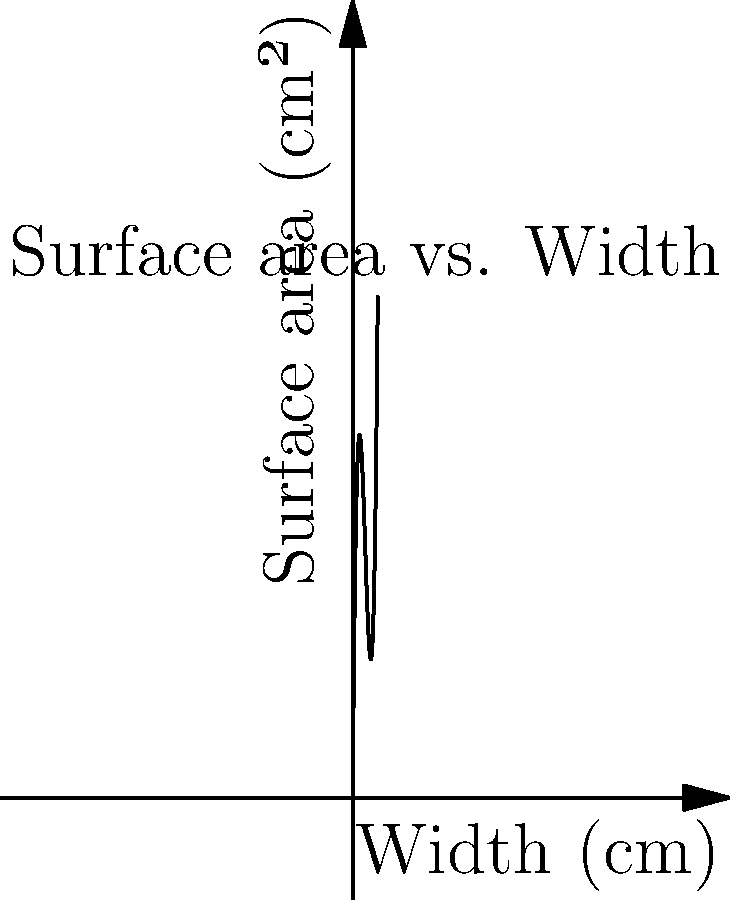As a seller of traditional Turkish decorations, you want to create a rectangular display case for a special Ottoman-era vase. The case should have a square base with width $x$ cm and height $10$ cm. The total surface area $S$ of the case is given by the function $S(x) = 2x^3 - 30x^2 + 120x$. What dimensions should you choose to minimize the surface area while ensuring the case has a volume of at least 1000 cm³? Let's approach this step-by-step:

1) First, we need to find the critical points of the surface area function:
   $S(x) = 2x^3 - 30x^2 + 120x$
   $S'(x) = 6x^2 - 60x + 120$
   Set $S'(x) = 0$:
   $6x^2 - 60x + 120 = 0$
   $x^2 - 10x + 20 = 0$
   $(x-5)^2 - 5 = 0$
   $x = 5 \pm \sqrt{5}$

2) The critical points are $x_1 = 5 + \sqrt{5}$ and $x_2 = 5 - \sqrt{5}$

3) Now, we need to check the volume constraint:
   Volume $V = x^2 \cdot 10 \geq 1000$
   $x^2 \geq 100$
   $x \geq 10$

4) Since $x$ must be at least 10, and both critical points are less than 10, we need to use $x = 10$ to minimize surface area while meeting the volume constraint.

5) The dimensions of the case should be:
   Width = Length = 10 cm
   Height = 10 cm

6) We can verify the surface area:
   $S(10) = 2(10)^3 - 30(10)^2 + 120(10) = 2000 - 3000 + 1200 = 200$ cm²

7) And the volume:
   $V = 10 \cdot 10 \cdot 10 = 1000$ cm³
Answer: 10 cm x 10 cm x 10 cm 